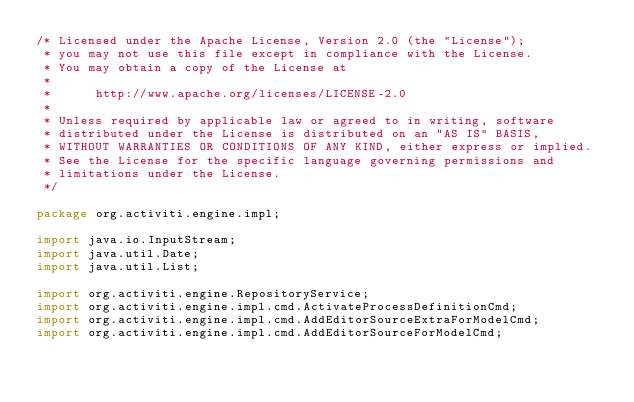Convert code to text. <code><loc_0><loc_0><loc_500><loc_500><_Java_>/* Licensed under the Apache License, Version 2.0 (the "License");
 * you may not use this file except in compliance with the License.
 * You may obtain a copy of the License at
 * 
 *      http://www.apache.org/licenses/LICENSE-2.0
 * 
 * Unless required by applicable law or agreed to in writing, software
 * distributed under the License is distributed on an "AS IS" BASIS,
 * WITHOUT WARRANTIES OR CONDITIONS OF ANY KIND, either express or implied.
 * See the License for the specific language governing permissions and
 * limitations under the License.
 */

package org.activiti.engine.impl;

import java.io.InputStream;
import java.util.Date;
import java.util.List;

import org.activiti.engine.RepositoryService;
import org.activiti.engine.impl.cmd.ActivateProcessDefinitionCmd;
import org.activiti.engine.impl.cmd.AddEditorSourceExtraForModelCmd;
import org.activiti.engine.impl.cmd.AddEditorSourceForModelCmd;</code> 